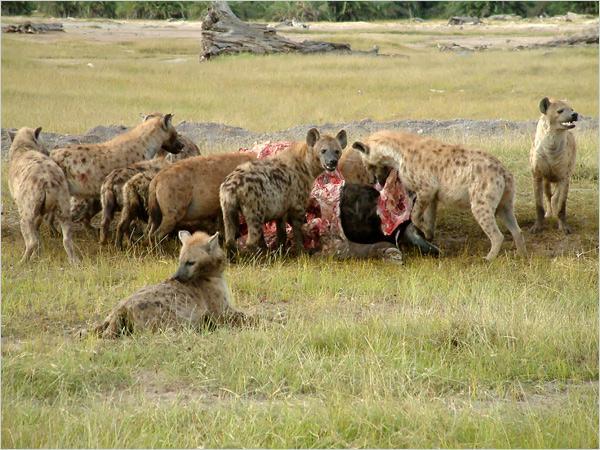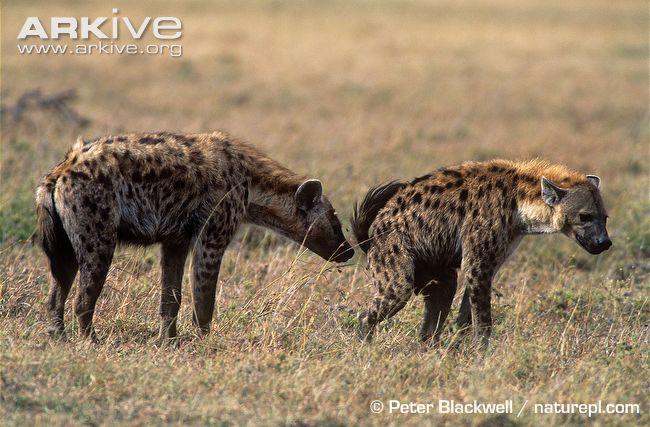The first image is the image on the left, the second image is the image on the right. For the images displayed, is the sentence "There are at most 4 hyenas in one of the images." factually correct? Answer yes or no. Yes. The first image is the image on the left, the second image is the image on the right. For the images displayed, is the sentence "There are more than eight hyenas." factually correct? Answer yes or no. Yes. 